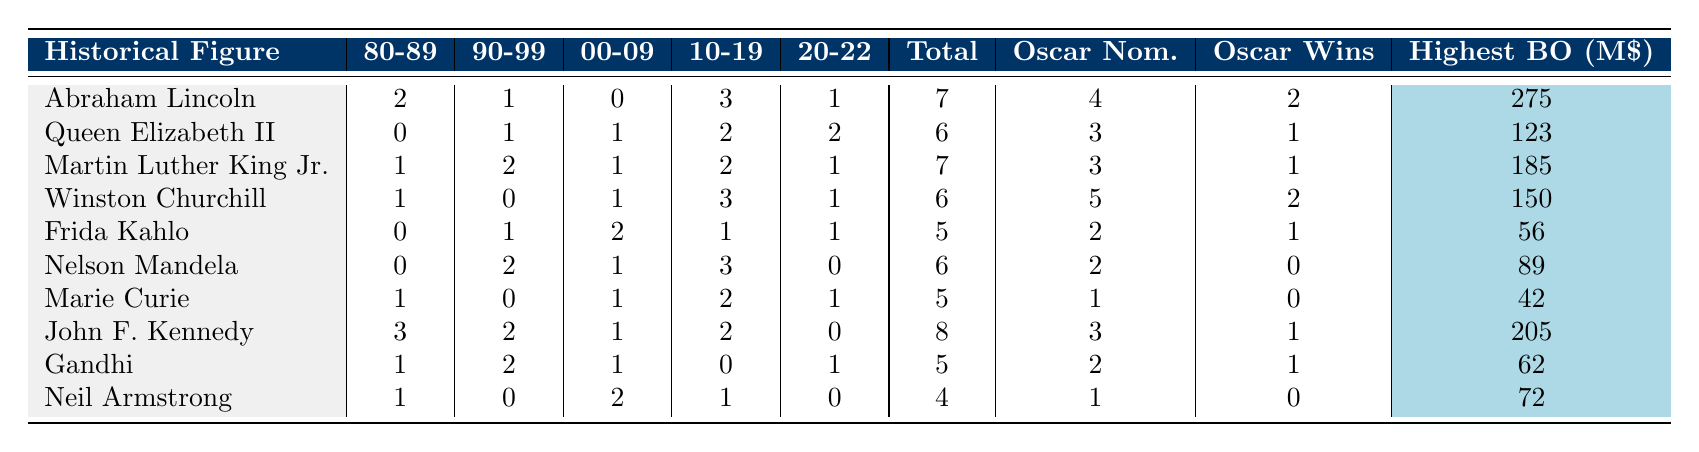What is the total number of biopics made about John F. Kennedy? The table shows that under the "Total Biopics" column for John F. Kennedy, the value is 8.
Answer: 8 Which historical figure has the highest number of Oscar nominations? By examining the "Oscar Nom." column, John F. Kennedy has the highest number with 3 nominations.
Answer: John F. Kennedy How many biopics were made about Winston Churchill from 1980 to 1999? Adding the values from the columns "80-89" (1) and "90-99" (0) gives a total of 1 biopic about Winston Churchill during that time period.
Answer: 1 Did Marie Curie win any Oscars for the biopics made about her? The "Oscar Wins" column for Marie Curie shows a value of 0, indicating she did not win any Oscars.
Answer: No What is the average number of Oscar wins for the historical figures represented in this table? Summing the Oscar wins gives 10 across all figures (2 + 1 + 1 + 2 + 1 + 0 + 0 + 1 + 1 + 0 = 10). With 10 historical figures, the average is 10/10 = 1.
Answer: 1 Which decade saw the highest number of biopics featuring Martin Luther King Jr.? Looking at the "Total Biopics" row for Martin Luther King Jr., the highest count is 7, which is observed from the years 1980 to 2022 without needing to analyze each decade separately.
Answer: 7 How does the number of biopics featuring Gandhi compare to those featuring Nelson Mandela? Gandhi has 5 biopics in total while Nelson Mandela has 6. Therefore, Nelson Mandela has 1 more biopic than Gandhi.
Answer: 1 more What is the highest box office earnings of any film based on the historical figures listed? The "Highest BO (M$)" column indicates that Abraham Lincoln has the highest earnings at 275 million USD.
Answer: 275 million USD How many biopics were made about Frida Kahlo from 2010 to 2022? Summing the values in the columns for Frida Kahlo gives: 1 (2010-2019) + 1 (2020-2022) = 2 biopics for that time frame.
Answer: 2 Which historical figure had more movie portrayals in the 1990s than in the 2000s? By comparing column values, Martin Luther King Jr. has 2 portrayals in the 1990s and only 1 in the 2000s, indicating he had more during that decade.
Answer: Martin Luther King Jr What is the difference in the total number of biopics between John F. Kennedy and Neil Armstrong? John F. Kennedy has 8 biopics and Neil Armstrong has 4. The difference is calculated as 8 - 4 = 4.
Answer: 4 